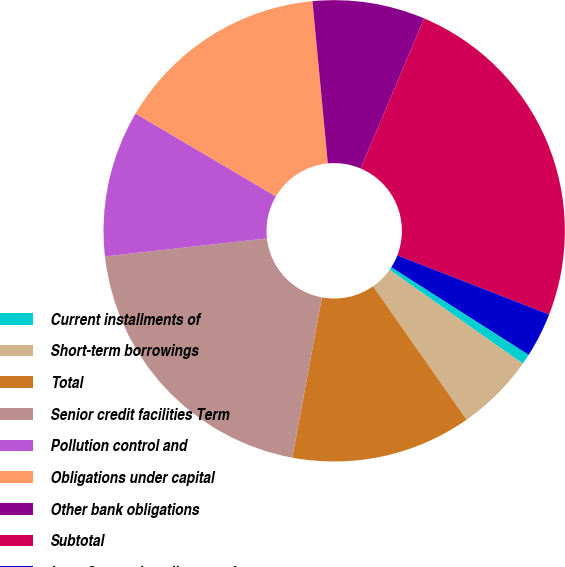Convert chart. <chart><loc_0><loc_0><loc_500><loc_500><pie_chart><fcel>Current installments of<fcel>Short-term borrowings<fcel>Total<fcel>Senior credit facilities Term<fcel>Pollution control and<fcel>Obligations under capital<fcel>Other bank obligations<fcel>Subtotal<fcel>Less Current installments of<nl><fcel>0.74%<fcel>5.5%<fcel>12.64%<fcel>20.32%<fcel>10.26%<fcel>15.01%<fcel>7.88%<fcel>24.53%<fcel>3.12%<nl></chart> 